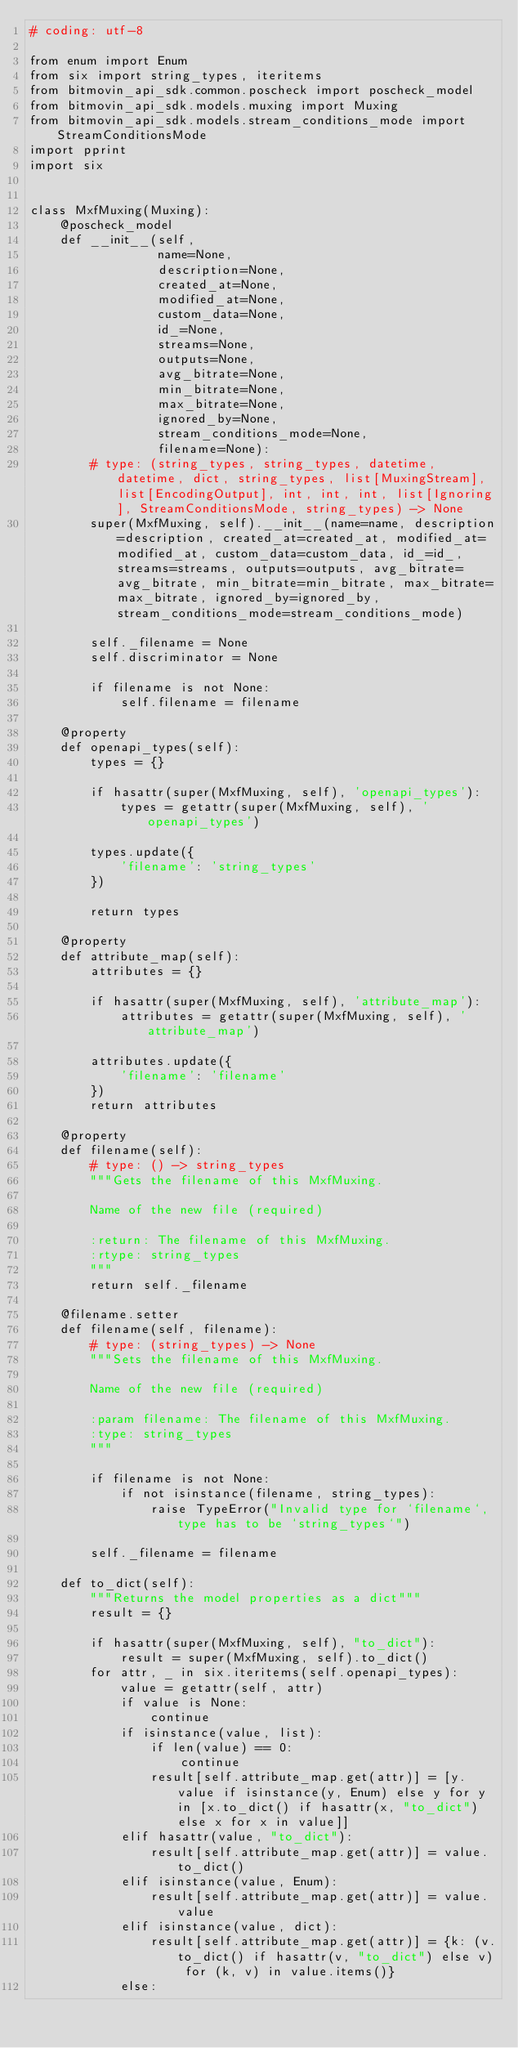Convert code to text. <code><loc_0><loc_0><loc_500><loc_500><_Python_># coding: utf-8

from enum import Enum
from six import string_types, iteritems
from bitmovin_api_sdk.common.poscheck import poscheck_model
from bitmovin_api_sdk.models.muxing import Muxing
from bitmovin_api_sdk.models.stream_conditions_mode import StreamConditionsMode
import pprint
import six


class MxfMuxing(Muxing):
    @poscheck_model
    def __init__(self,
                 name=None,
                 description=None,
                 created_at=None,
                 modified_at=None,
                 custom_data=None,
                 id_=None,
                 streams=None,
                 outputs=None,
                 avg_bitrate=None,
                 min_bitrate=None,
                 max_bitrate=None,
                 ignored_by=None,
                 stream_conditions_mode=None,
                 filename=None):
        # type: (string_types, string_types, datetime, datetime, dict, string_types, list[MuxingStream], list[EncodingOutput], int, int, int, list[Ignoring], StreamConditionsMode, string_types) -> None
        super(MxfMuxing, self).__init__(name=name, description=description, created_at=created_at, modified_at=modified_at, custom_data=custom_data, id_=id_, streams=streams, outputs=outputs, avg_bitrate=avg_bitrate, min_bitrate=min_bitrate, max_bitrate=max_bitrate, ignored_by=ignored_by, stream_conditions_mode=stream_conditions_mode)

        self._filename = None
        self.discriminator = None

        if filename is not None:
            self.filename = filename

    @property
    def openapi_types(self):
        types = {}

        if hasattr(super(MxfMuxing, self), 'openapi_types'):
            types = getattr(super(MxfMuxing, self), 'openapi_types')

        types.update({
            'filename': 'string_types'
        })

        return types

    @property
    def attribute_map(self):
        attributes = {}

        if hasattr(super(MxfMuxing, self), 'attribute_map'):
            attributes = getattr(super(MxfMuxing, self), 'attribute_map')

        attributes.update({
            'filename': 'filename'
        })
        return attributes

    @property
    def filename(self):
        # type: () -> string_types
        """Gets the filename of this MxfMuxing.

        Name of the new file (required)

        :return: The filename of this MxfMuxing.
        :rtype: string_types
        """
        return self._filename

    @filename.setter
    def filename(self, filename):
        # type: (string_types) -> None
        """Sets the filename of this MxfMuxing.

        Name of the new file (required)

        :param filename: The filename of this MxfMuxing.
        :type: string_types
        """

        if filename is not None:
            if not isinstance(filename, string_types):
                raise TypeError("Invalid type for `filename`, type has to be `string_types`")

        self._filename = filename

    def to_dict(self):
        """Returns the model properties as a dict"""
        result = {}

        if hasattr(super(MxfMuxing, self), "to_dict"):
            result = super(MxfMuxing, self).to_dict()
        for attr, _ in six.iteritems(self.openapi_types):
            value = getattr(self, attr)
            if value is None:
                continue
            if isinstance(value, list):
                if len(value) == 0:
                    continue
                result[self.attribute_map.get(attr)] = [y.value if isinstance(y, Enum) else y for y in [x.to_dict() if hasattr(x, "to_dict") else x for x in value]]
            elif hasattr(value, "to_dict"):
                result[self.attribute_map.get(attr)] = value.to_dict()
            elif isinstance(value, Enum):
                result[self.attribute_map.get(attr)] = value.value
            elif isinstance(value, dict):
                result[self.attribute_map.get(attr)] = {k: (v.to_dict() if hasattr(v, "to_dict") else v) for (k, v) in value.items()}
            else:</code> 